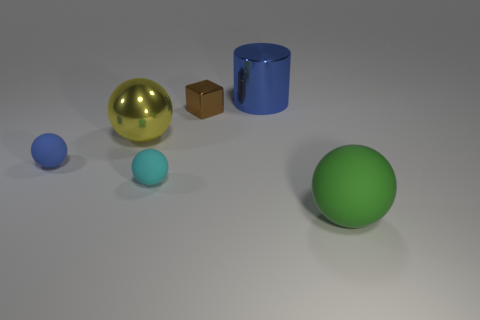There is a big object that is on the left side of the tiny matte sphere on the right side of the blue object in front of the big yellow sphere; what is it made of?
Provide a short and direct response. Metal. Are there any other tiny cubes of the same color as the cube?
Provide a short and direct response. No. Are there fewer small blue things right of the blue matte ball than yellow metal objects?
Give a very brief answer. Yes. There is a metallic object that is right of the brown thing; is its size the same as the yellow shiny sphere?
Provide a short and direct response. Yes. What number of things are behind the cyan matte ball and on the left side of the cylinder?
Keep it short and to the point. 3. What is the size of the matte thing right of the small matte thing that is in front of the small blue rubber thing?
Ensure brevity in your answer.  Large. Are there fewer cyan balls on the right side of the tiny brown metallic cube than brown shiny things that are on the right side of the large metallic cylinder?
Ensure brevity in your answer.  No. Do the thing behind the brown shiny cube and the big metal thing in front of the large shiny cylinder have the same color?
Make the answer very short. No. What is the material of the object that is on the right side of the brown thing and behind the green thing?
Keep it short and to the point. Metal. Are any big shiny objects visible?
Your response must be concise. Yes. 